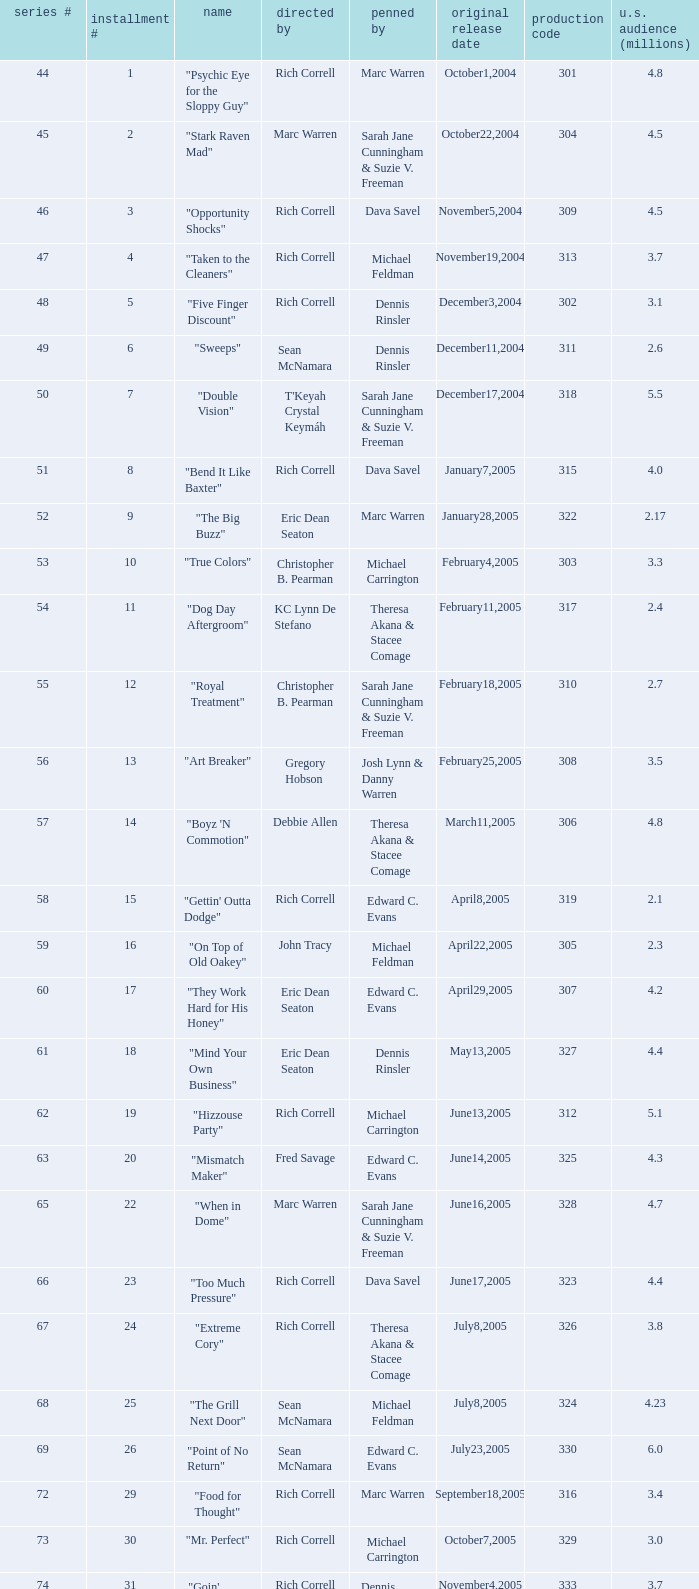What is the title of the episode directed by Rich Correll and written by Dennis Rinsler? "Five Finger Discount". 